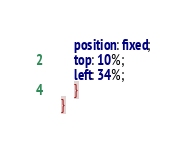Convert code to text. <code><loc_0><loc_0><loc_500><loc_500><_CSS_>        position: fixed;
        top: 10%;
        left: 34%;
        }
    }</code> 